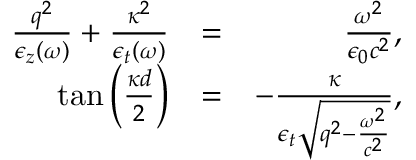Convert formula to latex. <formula><loc_0><loc_0><loc_500><loc_500>\begin{array} { r l r } { \frac { q ^ { 2 } } { \epsilon _ { z } ( \omega ) } + \frac { \kappa ^ { 2 } } { \epsilon _ { t } ( \omega ) } } & { = } & { \frac { \omega ^ { 2 } } { \epsilon _ { 0 } c ^ { 2 } } , } \\ { \tan \left ( \frac { \kappa d } { 2 } \right ) } & { = } & { - \frac { \kappa } { \epsilon _ { t } \sqrt { q ^ { 2 } - \frac { \omega ^ { 2 } } { c ^ { 2 } } } } , } \end{array}</formula> 